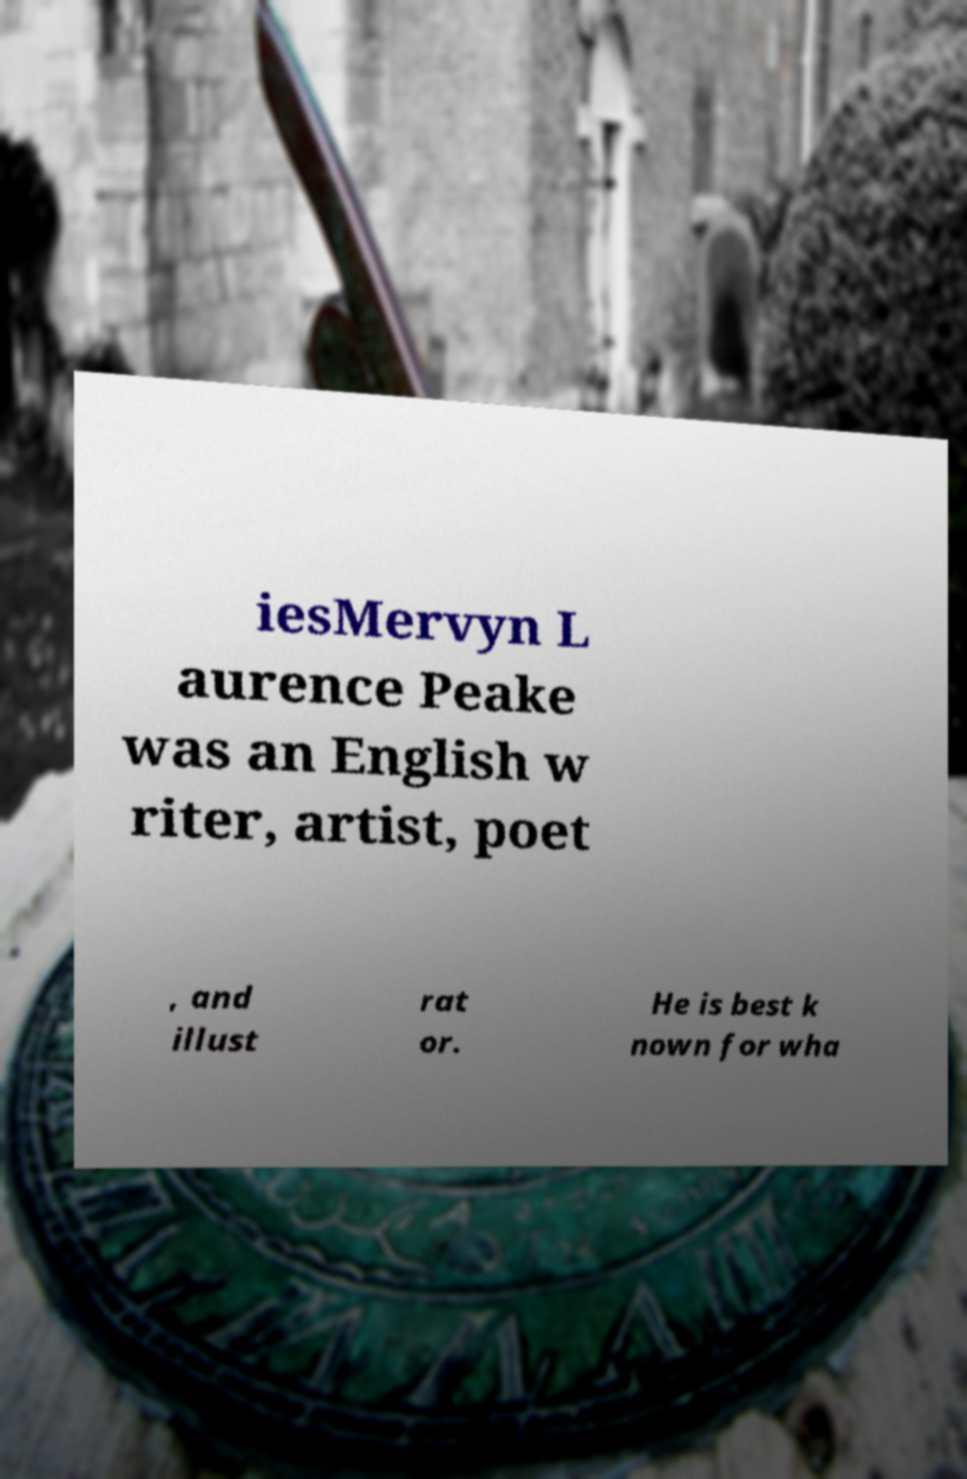For documentation purposes, I need the text within this image transcribed. Could you provide that? iesMervyn L aurence Peake was an English w riter, artist, poet , and illust rat or. He is best k nown for wha 